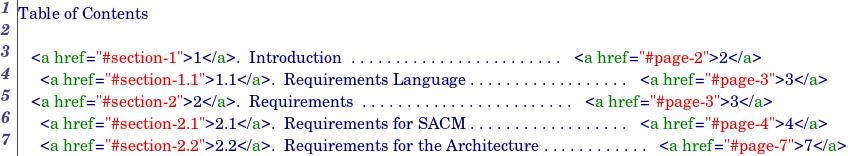<code> <loc_0><loc_0><loc_500><loc_500><_HTML_>
Table of Contents

   <a href="#section-1">1</a>.  Introduction  . . . . . . . . . . . . . . . . . . . . . . . .   <a href="#page-2">2</a>
     <a href="#section-1.1">1.1</a>.  Requirements Language . . . . . . . . . . . . . . . . . .   <a href="#page-3">3</a>
   <a href="#section-2">2</a>.  Requirements  . . . . . . . . . . . . . . . . . . . . . . . .   <a href="#page-3">3</a>
     <a href="#section-2.1">2.1</a>.  Requirements for SACM . . . . . . . . . . . . . . . . . .   <a href="#page-4">4</a>
     <a href="#section-2.2">2.2</a>.  Requirements for the Architecture . . . . . . . . . . . .   <a href="#page-7">7</a></code> 